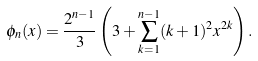Convert formula to latex. <formula><loc_0><loc_0><loc_500><loc_500>\phi _ { n } ( x ) = \frac { 2 ^ { n - 1 } } { 3 } \left ( 3 + \sum _ { k = 1 } ^ { n - 1 } ( k + 1 ) ^ { 2 } x ^ { 2 k } \right ) .</formula> 